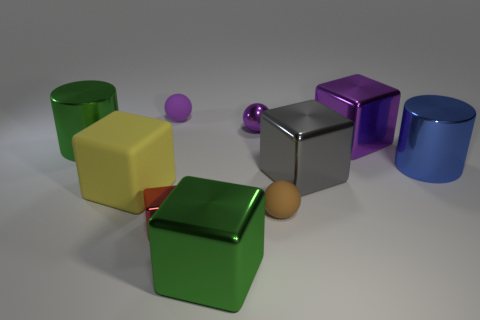Subtract all green blocks. How many blocks are left? 4 Subtract 2 cubes. How many cubes are left? 3 Subtract all large rubber blocks. How many blocks are left? 4 Subtract all cyan cubes. Subtract all red cylinders. How many cubes are left? 5 Subtract all spheres. How many objects are left? 7 Add 3 big blue matte balls. How many big blue matte balls exist? 3 Subtract 0 blue spheres. How many objects are left? 10 Subtract all small cubes. Subtract all small matte objects. How many objects are left? 7 Add 3 red metal blocks. How many red metal blocks are left? 4 